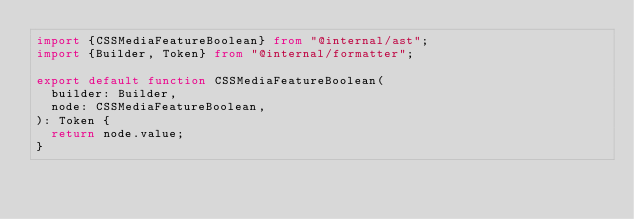<code> <loc_0><loc_0><loc_500><loc_500><_TypeScript_>import {CSSMediaFeatureBoolean} from "@internal/ast";
import {Builder, Token} from "@internal/formatter";

export default function CSSMediaFeatureBoolean(
	builder: Builder,
	node: CSSMediaFeatureBoolean,
): Token {
	return node.value;
}
</code> 